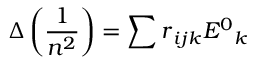Convert formula to latex. <formula><loc_0><loc_0><loc_500><loc_500>\Delta \left ( \frac { 1 } { n ^ { 2 } } \right ) = \sum r { _ { i j k } } E { ^ { 0 } } { _ { k } }</formula> 